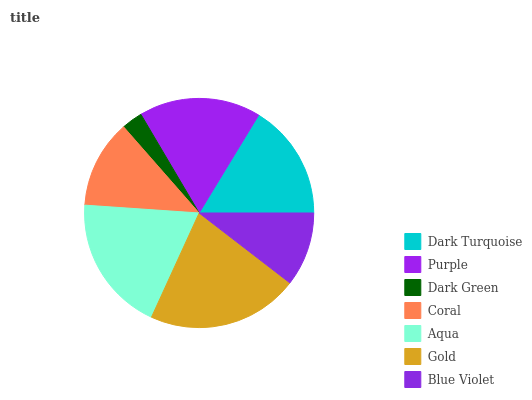Is Dark Green the minimum?
Answer yes or no. Yes. Is Gold the maximum?
Answer yes or no. Yes. Is Purple the minimum?
Answer yes or no. No. Is Purple the maximum?
Answer yes or no. No. Is Purple greater than Dark Turquoise?
Answer yes or no. Yes. Is Dark Turquoise less than Purple?
Answer yes or no. Yes. Is Dark Turquoise greater than Purple?
Answer yes or no. No. Is Purple less than Dark Turquoise?
Answer yes or no. No. Is Dark Turquoise the high median?
Answer yes or no. Yes. Is Dark Turquoise the low median?
Answer yes or no. Yes. Is Dark Green the high median?
Answer yes or no. No. Is Purple the low median?
Answer yes or no. No. 